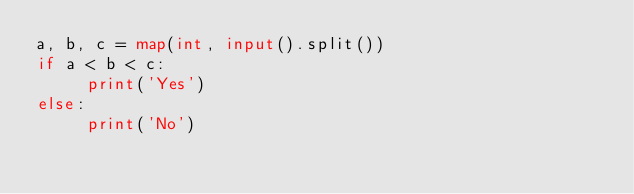<code> <loc_0><loc_0><loc_500><loc_500><_Python_>a, b, c = map(int, input().split())
if a < b < c:
     print('Yes')
else:
     print('No')</code> 